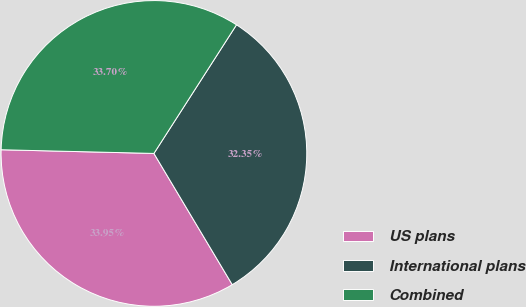Convert chart. <chart><loc_0><loc_0><loc_500><loc_500><pie_chart><fcel>US plans<fcel>International plans<fcel>Combined<nl><fcel>33.95%<fcel>32.35%<fcel>33.7%<nl></chart> 